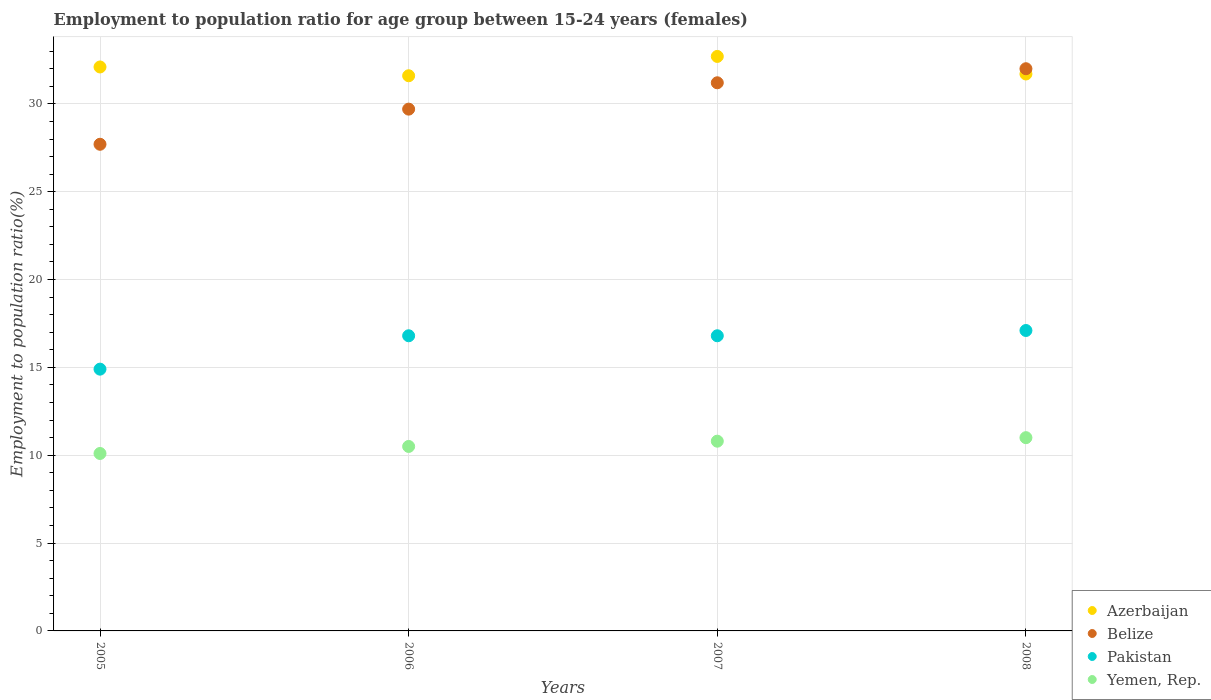What is the employment to population ratio in Pakistan in 2005?
Your answer should be compact. 14.9. Across all years, what is the maximum employment to population ratio in Pakistan?
Provide a short and direct response. 17.1. Across all years, what is the minimum employment to population ratio in Azerbaijan?
Make the answer very short. 31.6. In which year was the employment to population ratio in Belize maximum?
Your answer should be very brief. 2008. In which year was the employment to population ratio in Azerbaijan minimum?
Ensure brevity in your answer.  2006. What is the total employment to population ratio in Pakistan in the graph?
Your response must be concise. 65.6. What is the difference between the employment to population ratio in Pakistan in 2006 and that in 2008?
Provide a short and direct response. -0.3. What is the difference between the employment to population ratio in Pakistan in 2005 and the employment to population ratio in Belize in 2008?
Keep it short and to the point. -17.1. What is the average employment to population ratio in Azerbaijan per year?
Offer a very short reply. 32.03. In the year 2007, what is the difference between the employment to population ratio in Yemen, Rep. and employment to population ratio in Belize?
Your response must be concise. -20.4. In how many years, is the employment to population ratio in Belize greater than 9 %?
Give a very brief answer. 4. What is the ratio of the employment to population ratio in Pakistan in 2005 to that in 2008?
Provide a short and direct response. 0.87. Is the difference between the employment to population ratio in Yemen, Rep. in 2006 and 2007 greater than the difference between the employment to population ratio in Belize in 2006 and 2007?
Provide a short and direct response. Yes. What is the difference between the highest and the second highest employment to population ratio in Pakistan?
Your answer should be compact. 0.3. What is the difference between the highest and the lowest employment to population ratio in Yemen, Rep.?
Your answer should be compact. 0.9. In how many years, is the employment to population ratio in Yemen, Rep. greater than the average employment to population ratio in Yemen, Rep. taken over all years?
Offer a very short reply. 2. Is the sum of the employment to population ratio in Azerbaijan in 2006 and 2007 greater than the maximum employment to population ratio in Pakistan across all years?
Provide a short and direct response. Yes. Is it the case that in every year, the sum of the employment to population ratio in Belize and employment to population ratio in Pakistan  is greater than the sum of employment to population ratio in Yemen, Rep. and employment to population ratio in Azerbaijan?
Offer a very short reply. No. Does the employment to population ratio in Azerbaijan monotonically increase over the years?
Offer a terse response. No. What is the difference between two consecutive major ticks on the Y-axis?
Ensure brevity in your answer.  5. Are the values on the major ticks of Y-axis written in scientific E-notation?
Keep it short and to the point. No. How many legend labels are there?
Provide a succinct answer. 4. What is the title of the graph?
Offer a very short reply. Employment to population ratio for age group between 15-24 years (females). What is the label or title of the X-axis?
Make the answer very short. Years. What is the Employment to population ratio(%) of Azerbaijan in 2005?
Offer a terse response. 32.1. What is the Employment to population ratio(%) of Belize in 2005?
Ensure brevity in your answer.  27.7. What is the Employment to population ratio(%) of Pakistan in 2005?
Ensure brevity in your answer.  14.9. What is the Employment to population ratio(%) of Yemen, Rep. in 2005?
Your answer should be compact. 10.1. What is the Employment to population ratio(%) of Azerbaijan in 2006?
Ensure brevity in your answer.  31.6. What is the Employment to population ratio(%) of Belize in 2006?
Make the answer very short. 29.7. What is the Employment to population ratio(%) of Pakistan in 2006?
Your answer should be compact. 16.8. What is the Employment to population ratio(%) in Azerbaijan in 2007?
Ensure brevity in your answer.  32.7. What is the Employment to population ratio(%) in Belize in 2007?
Give a very brief answer. 31.2. What is the Employment to population ratio(%) in Pakistan in 2007?
Ensure brevity in your answer.  16.8. What is the Employment to population ratio(%) in Yemen, Rep. in 2007?
Offer a very short reply. 10.8. What is the Employment to population ratio(%) of Azerbaijan in 2008?
Offer a very short reply. 31.7. What is the Employment to population ratio(%) in Belize in 2008?
Provide a succinct answer. 32. What is the Employment to population ratio(%) in Pakistan in 2008?
Your response must be concise. 17.1. What is the Employment to population ratio(%) of Yemen, Rep. in 2008?
Make the answer very short. 11. Across all years, what is the maximum Employment to population ratio(%) in Azerbaijan?
Keep it short and to the point. 32.7. Across all years, what is the maximum Employment to population ratio(%) of Belize?
Your answer should be compact. 32. Across all years, what is the maximum Employment to population ratio(%) of Pakistan?
Keep it short and to the point. 17.1. Across all years, what is the maximum Employment to population ratio(%) in Yemen, Rep.?
Provide a succinct answer. 11. Across all years, what is the minimum Employment to population ratio(%) of Azerbaijan?
Make the answer very short. 31.6. Across all years, what is the minimum Employment to population ratio(%) of Belize?
Ensure brevity in your answer.  27.7. Across all years, what is the minimum Employment to population ratio(%) of Pakistan?
Offer a very short reply. 14.9. Across all years, what is the minimum Employment to population ratio(%) in Yemen, Rep.?
Your answer should be compact. 10.1. What is the total Employment to population ratio(%) of Azerbaijan in the graph?
Provide a succinct answer. 128.1. What is the total Employment to population ratio(%) in Belize in the graph?
Provide a succinct answer. 120.6. What is the total Employment to population ratio(%) of Pakistan in the graph?
Keep it short and to the point. 65.6. What is the total Employment to population ratio(%) of Yemen, Rep. in the graph?
Give a very brief answer. 42.4. What is the difference between the Employment to population ratio(%) in Belize in 2005 and that in 2006?
Offer a terse response. -2. What is the difference between the Employment to population ratio(%) of Pakistan in 2005 and that in 2006?
Provide a short and direct response. -1.9. What is the difference between the Employment to population ratio(%) of Yemen, Rep. in 2005 and that in 2006?
Your response must be concise. -0.4. What is the difference between the Employment to population ratio(%) in Azerbaijan in 2005 and that in 2007?
Provide a succinct answer. -0.6. What is the difference between the Employment to population ratio(%) of Yemen, Rep. in 2005 and that in 2007?
Provide a short and direct response. -0.7. What is the difference between the Employment to population ratio(%) of Belize in 2005 and that in 2008?
Offer a very short reply. -4.3. What is the difference between the Employment to population ratio(%) of Pakistan in 2005 and that in 2008?
Offer a very short reply. -2.2. What is the difference between the Employment to population ratio(%) in Pakistan in 2006 and that in 2007?
Offer a terse response. 0. What is the difference between the Employment to population ratio(%) of Pakistan in 2007 and that in 2008?
Give a very brief answer. -0.3. What is the difference between the Employment to population ratio(%) of Yemen, Rep. in 2007 and that in 2008?
Keep it short and to the point. -0.2. What is the difference between the Employment to population ratio(%) of Azerbaijan in 2005 and the Employment to population ratio(%) of Yemen, Rep. in 2006?
Make the answer very short. 21.6. What is the difference between the Employment to population ratio(%) in Pakistan in 2005 and the Employment to population ratio(%) in Yemen, Rep. in 2006?
Provide a short and direct response. 4.4. What is the difference between the Employment to population ratio(%) of Azerbaijan in 2005 and the Employment to population ratio(%) of Yemen, Rep. in 2007?
Give a very brief answer. 21.3. What is the difference between the Employment to population ratio(%) in Belize in 2005 and the Employment to population ratio(%) in Yemen, Rep. in 2007?
Provide a succinct answer. 16.9. What is the difference between the Employment to population ratio(%) in Azerbaijan in 2005 and the Employment to population ratio(%) in Belize in 2008?
Make the answer very short. 0.1. What is the difference between the Employment to population ratio(%) of Azerbaijan in 2005 and the Employment to population ratio(%) of Yemen, Rep. in 2008?
Offer a very short reply. 21.1. What is the difference between the Employment to population ratio(%) in Belize in 2005 and the Employment to population ratio(%) in Yemen, Rep. in 2008?
Your answer should be very brief. 16.7. What is the difference between the Employment to population ratio(%) in Pakistan in 2005 and the Employment to population ratio(%) in Yemen, Rep. in 2008?
Give a very brief answer. 3.9. What is the difference between the Employment to population ratio(%) of Azerbaijan in 2006 and the Employment to population ratio(%) of Belize in 2007?
Keep it short and to the point. 0.4. What is the difference between the Employment to population ratio(%) of Azerbaijan in 2006 and the Employment to population ratio(%) of Pakistan in 2007?
Offer a terse response. 14.8. What is the difference between the Employment to population ratio(%) in Azerbaijan in 2006 and the Employment to population ratio(%) in Yemen, Rep. in 2007?
Provide a succinct answer. 20.8. What is the difference between the Employment to population ratio(%) of Belize in 2006 and the Employment to population ratio(%) of Yemen, Rep. in 2007?
Your answer should be very brief. 18.9. What is the difference between the Employment to population ratio(%) of Azerbaijan in 2006 and the Employment to population ratio(%) of Belize in 2008?
Your answer should be very brief. -0.4. What is the difference between the Employment to population ratio(%) of Azerbaijan in 2006 and the Employment to population ratio(%) of Yemen, Rep. in 2008?
Your answer should be very brief. 20.6. What is the difference between the Employment to population ratio(%) in Belize in 2006 and the Employment to population ratio(%) in Pakistan in 2008?
Your response must be concise. 12.6. What is the difference between the Employment to population ratio(%) of Belize in 2006 and the Employment to population ratio(%) of Yemen, Rep. in 2008?
Ensure brevity in your answer.  18.7. What is the difference between the Employment to population ratio(%) in Azerbaijan in 2007 and the Employment to population ratio(%) in Belize in 2008?
Your response must be concise. 0.7. What is the difference between the Employment to population ratio(%) in Azerbaijan in 2007 and the Employment to population ratio(%) in Yemen, Rep. in 2008?
Provide a succinct answer. 21.7. What is the difference between the Employment to population ratio(%) in Belize in 2007 and the Employment to population ratio(%) in Yemen, Rep. in 2008?
Keep it short and to the point. 20.2. What is the difference between the Employment to population ratio(%) of Pakistan in 2007 and the Employment to population ratio(%) of Yemen, Rep. in 2008?
Your response must be concise. 5.8. What is the average Employment to population ratio(%) in Azerbaijan per year?
Your response must be concise. 32.02. What is the average Employment to population ratio(%) of Belize per year?
Keep it short and to the point. 30.15. In the year 2005, what is the difference between the Employment to population ratio(%) in Azerbaijan and Employment to population ratio(%) in Belize?
Offer a very short reply. 4.4. In the year 2005, what is the difference between the Employment to population ratio(%) of Pakistan and Employment to population ratio(%) of Yemen, Rep.?
Make the answer very short. 4.8. In the year 2006, what is the difference between the Employment to population ratio(%) in Azerbaijan and Employment to population ratio(%) in Yemen, Rep.?
Your response must be concise. 21.1. In the year 2006, what is the difference between the Employment to population ratio(%) in Belize and Employment to population ratio(%) in Yemen, Rep.?
Offer a very short reply. 19.2. In the year 2006, what is the difference between the Employment to population ratio(%) of Pakistan and Employment to population ratio(%) of Yemen, Rep.?
Give a very brief answer. 6.3. In the year 2007, what is the difference between the Employment to population ratio(%) of Azerbaijan and Employment to population ratio(%) of Pakistan?
Give a very brief answer. 15.9. In the year 2007, what is the difference between the Employment to population ratio(%) of Azerbaijan and Employment to population ratio(%) of Yemen, Rep.?
Your response must be concise. 21.9. In the year 2007, what is the difference between the Employment to population ratio(%) of Belize and Employment to population ratio(%) of Pakistan?
Provide a short and direct response. 14.4. In the year 2007, what is the difference between the Employment to population ratio(%) in Belize and Employment to population ratio(%) in Yemen, Rep.?
Your response must be concise. 20.4. In the year 2007, what is the difference between the Employment to population ratio(%) of Pakistan and Employment to population ratio(%) of Yemen, Rep.?
Offer a very short reply. 6. In the year 2008, what is the difference between the Employment to population ratio(%) in Azerbaijan and Employment to population ratio(%) in Belize?
Offer a terse response. -0.3. In the year 2008, what is the difference between the Employment to population ratio(%) of Azerbaijan and Employment to population ratio(%) of Pakistan?
Make the answer very short. 14.6. In the year 2008, what is the difference between the Employment to population ratio(%) of Azerbaijan and Employment to population ratio(%) of Yemen, Rep.?
Your answer should be compact. 20.7. In the year 2008, what is the difference between the Employment to population ratio(%) in Belize and Employment to population ratio(%) in Pakistan?
Provide a short and direct response. 14.9. In the year 2008, what is the difference between the Employment to population ratio(%) in Belize and Employment to population ratio(%) in Yemen, Rep.?
Make the answer very short. 21. What is the ratio of the Employment to population ratio(%) of Azerbaijan in 2005 to that in 2006?
Your answer should be very brief. 1.02. What is the ratio of the Employment to population ratio(%) of Belize in 2005 to that in 2006?
Offer a terse response. 0.93. What is the ratio of the Employment to population ratio(%) of Pakistan in 2005 to that in 2006?
Ensure brevity in your answer.  0.89. What is the ratio of the Employment to population ratio(%) of Yemen, Rep. in 2005 to that in 2006?
Provide a short and direct response. 0.96. What is the ratio of the Employment to population ratio(%) in Azerbaijan in 2005 to that in 2007?
Give a very brief answer. 0.98. What is the ratio of the Employment to population ratio(%) of Belize in 2005 to that in 2007?
Provide a succinct answer. 0.89. What is the ratio of the Employment to population ratio(%) of Pakistan in 2005 to that in 2007?
Keep it short and to the point. 0.89. What is the ratio of the Employment to population ratio(%) in Yemen, Rep. in 2005 to that in 2007?
Keep it short and to the point. 0.94. What is the ratio of the Employment to population ratio(%) of Azerbaijan in 2005 to that in 2008?
Provide a succinct answer. 1.01. What is the ratio of the Employment to population ratio(%) of Belize in 2005 to that in 2008?
Your answer should be compact. 0.87. What is the ratio of the Employment to population ratio(%) in Pakistan in 2005 to that in 2008?
Provide a short and direct response. 0.87. What is the ratio of the Employment to population ratio(%) in Yemen, Rep. in 2005 to that in 2008?
Your answer should be compact. 0.92. What is the ratio of the Employment to population ratio(%) of Azerbaijan in 2006 to that in 2007?
Make the answer very short. 0.97. What is the ratio of the Employment to population ratio(%) of Belize in 2006 to that in 2007?
Make the answer very short. 0.95. What is the ratio of the Employment to population ratio(%) in Yemen, Rep. in 2006 to that in 2007?
Your response must be concise. 0.97. What is the ratio of the Employment to population ratio(%) of Belize in 2006 to that in 2008?
Your answer should be very brief. 0.93. What is the ratio of the Employment to population ratio(%) of Pakistan in 2006 to that in 2008?
Provide a short and direct response. 0.98. What is the ratio of the Employment to population ratio(%) in Yemen, Rep. in 2006 to that in 2008?
Give a very brief answer. 0.95. What is the ratio of the Employment to population ratio(%) of Azerbaijan in 2007 to that in 2008?
Your response must be concise. 1.03. What is the ratio of the Employment to population ratio(%) in Belize in 2007 to that in 2008?
Your answer should be very brief. 0.97. What is the ratio of the Employment to population ratio(%) in Pakistan in 2007 to that in 2008?
Your answer should be very brief. 0.98. What is the ratio of the Employment to population ratio(%) of Yemen, Rep. in 2007 to that in 2008?
Provide a short and direct response. 0.98. What is the difference between the highest and the second highest Employment to population ratio(%) of Azerbaijan?
Your answer should be very brief. 0.6. What is the difference between the highest and the second highest Employment to population ratio(%) in Belize?
Keep it short and to the point. 0.8. What is the difference between the highest and the second highest Employment to population ratio(%) in Yemen, Rep.?
Ensure brevity in your answer.  0.2. What is the difference between the highest and the lowest Employment to population ratio(%) of Belize?
Offer a terse response. 4.3. What is the difference between the highest and the lowest Employment to population ratio(%) of Pakistan?
Your response must be concise. 2.2. What is the difference between the highest and the lowest Employment to population ratio(%) of Yemen, Rep.?
Your answer should be compact. 0.9. 